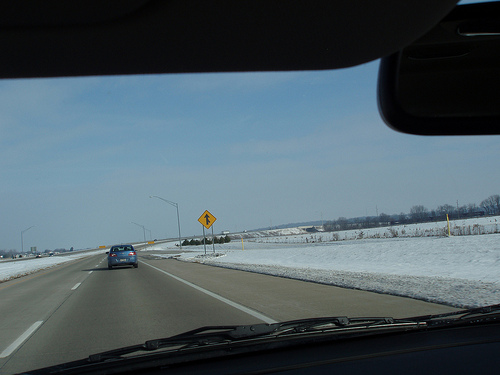<image>
Can you confirm if the car is in front of the car? Yes. The car is positioned in front of the car, appearing closer to the camera viewpoint. 